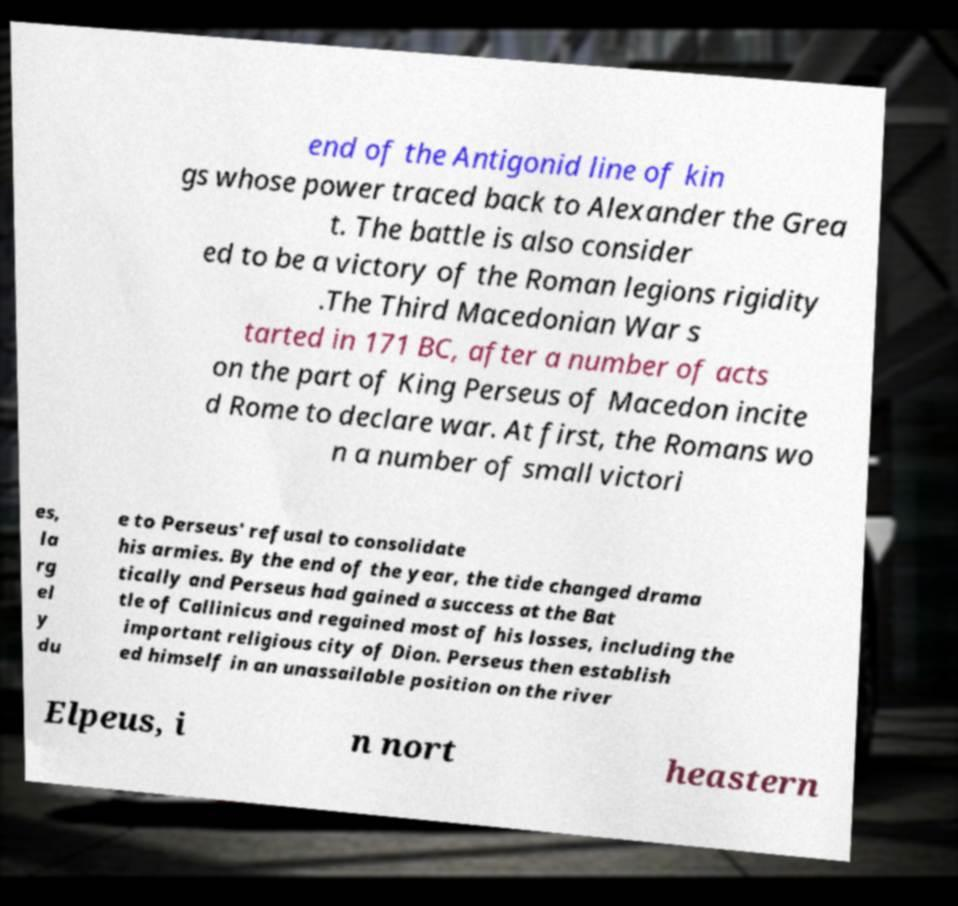For documentation purposes, I need the text within this image transcribed. Could you provide that? end of the Antigonid line of kin gs whose power traced back to Alexander the Grea t. The battle is also consider ed to be a victory of the Roman legions rigidity .The Third Macedonian War s tarted in 171 BC, after a number of acts on the part of King Perseus of Macedon incite d Rome to declare war. At first, the Romans wo n a number of small victori es, la rg el y du e to Perseus' refusal to consolidate his armies. By the end of the year, the tide changed drama tically and Perseus had gained a success at the Bat tle of Callinicus and regained most of his losses, including the important religious city of Dion. Perseus then establish ed himself in an unassailable position on the river Elpeus, i n nort heastern 